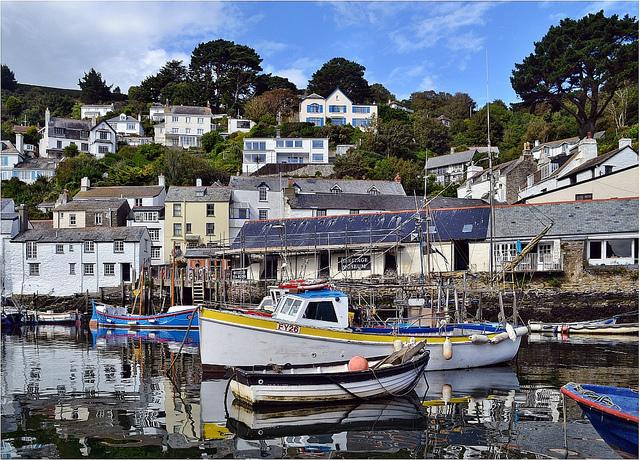Are there houses on the hillside?
Answer briefly. Yes. How many rowboats are visible?
Short answer required. 1. Where is this scene taken?
Write a very short answer. Harbor. 